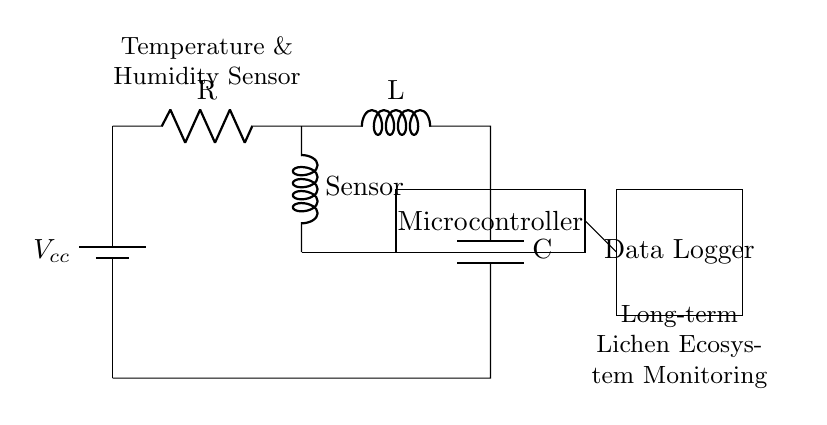what is the main function of the temperature and humidity sensor? The main function of the temperature and humidity sensor is to measure the environmental conditions, which are critical for monitoring the lichen ecosystems.
Answer: measure environmental conditions what components make up the RLC circuit in this diagram? The RLC circuit consists of a resistor, an inductor, and a capacitor which are all connected in series.
Answer: resistor, inductor, capacitor what does the microcontroller do in this circuit? The microcontroller processes the data collected from the temperature and humidity sensor and regulates the data logger's operations.
Answer: processes data how are the components powered in this circuit? The components are powered by the battery, labeled as Vcc, which supplies electrical energy to the circuit.
Answer: battery what is the role of the data logger in this system? The data logger records and stores the information received from the microcontroller for long-term analysis of the lichen ecosystems.
Answer: records data how does the inductor relate to the overall performance of this RLC circuit? The inductor helps in filtering and stabilizing the circuit's response to changes in the voltage and current, affecting the frequency response and energy storage.
Answer: stabilizes response which part of the circuit is responsible for long-term monitoring? The data logger is specifically designed for long-term monitoring by continually storing data over an extended period.
Answer: data logger 